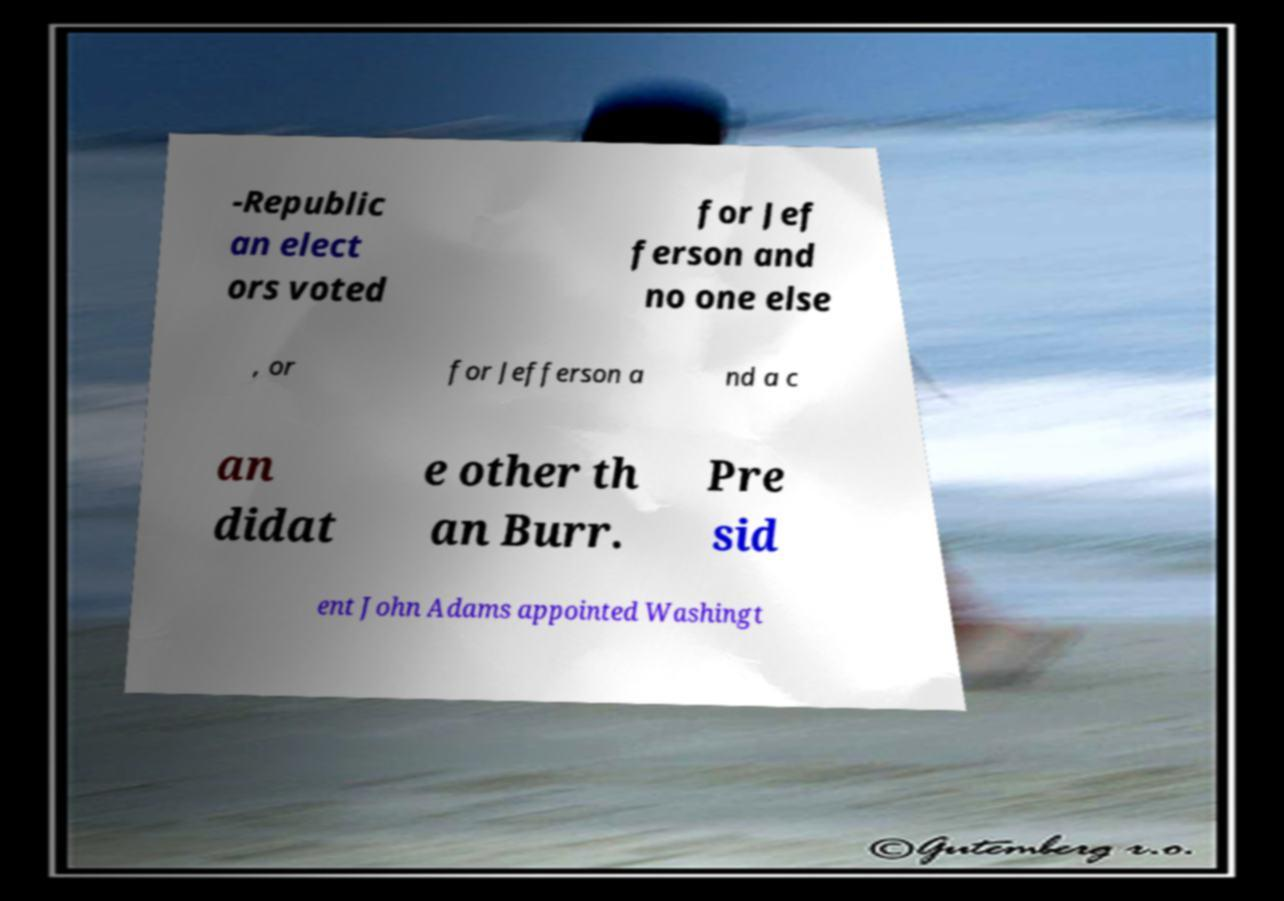Can you accurately transcribe the text from the provided image for me? -Republic an elect ors voted for Jef ferson and no one else , or for Jefferson a nd a c an didat e other th an Burr. Pre sid ent John Adams appointed Washingt 